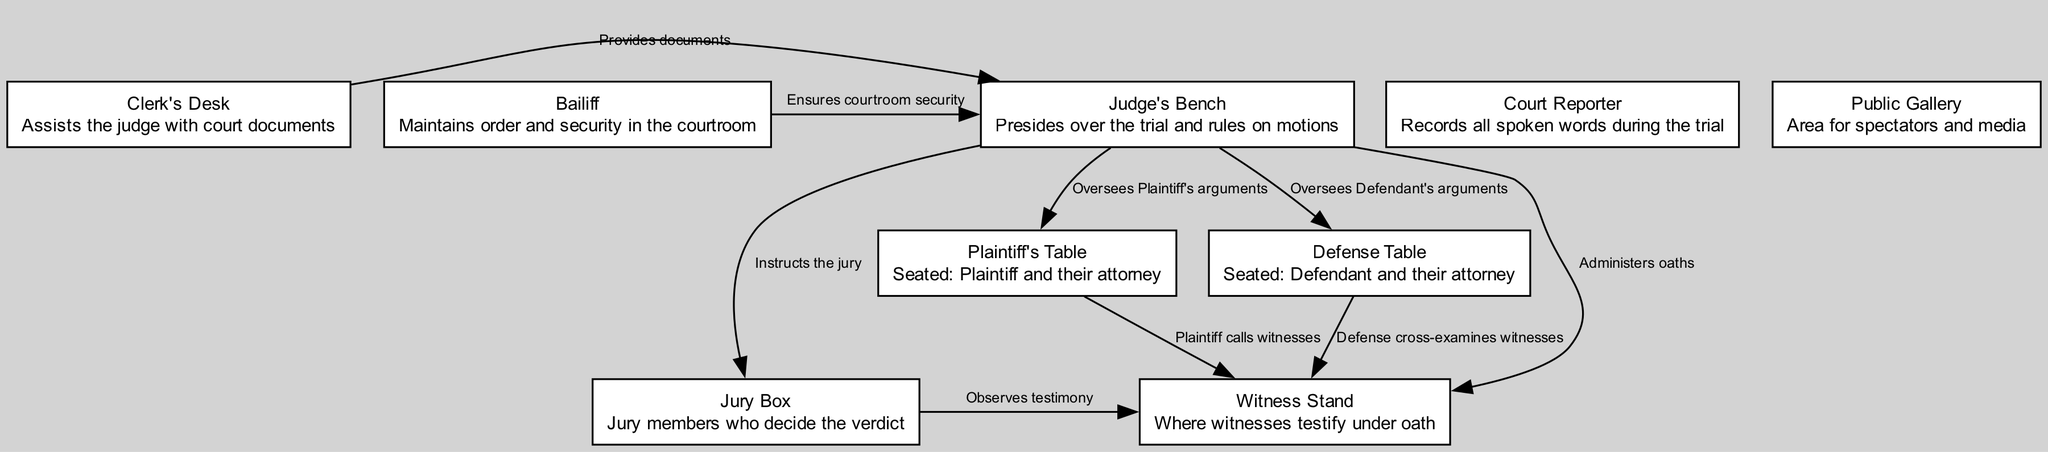What is located at the Judge's Bench? The Judge's Bench is described as presiding over the trial and ruling on motions, indicating that it signifies the presence of the judge who oversees the trial proceedings.
Answer: presides over the trial How many tables are present in the courtroom? There are two tables specified, the Plaintiff's Table and the Defense Table, each indicating the seating for the respective parties and their attorneys during the trial.
Answer: 2 tables Who administers oaths to witnesses? The Judge's Bench administers oaths to witnesses, which indicates that the judge is responsible for ensuring the witnesses testify truthfully under the authority of the court.
Answer: Judge What is the role of the Clerk's Desk? The role of the Clerk's Desk is to assist the judge with court documents, indicating that the clerk provides administrative support to the judge during the trial.
Answer: assists the judge Which group observes the testimony of witnesses? The Jury Box is noted as the area where jury members observe the testimony given by witnesses, signifying their role in evaluating evidence presented during the trial.
Answer: Jury Box Which table does the Plaintiff call witnesses from? The Plaintiff's Table is identified as the location from which the plaintiff calls witnesses, meaning it is where the plaintiff's attorney initiates the process of bringing witnesses to testify.
Answer: Plaintiff's Table What does the Bailiff ensure? The Bailiff is responsible for maintaining order and security in the courtroom, implying that this role is crucial for upholding the decorum of trial proceedings.
Answer: order and security What is the relationship between the Judge's Bench and the Jury Box? The Judge's Bench instructs the jury, indicating a direct relationship where the judge guides the jury on legal matters and how to consider the information presented.
Answer: instructs the jury Who sits at the Defense Table? The Defense Table is described as being seated by the defendant and their attorney, identifying the parties involved in defending against the plaintiff's claims during the trial.
Answer: Defendant and their attorney 